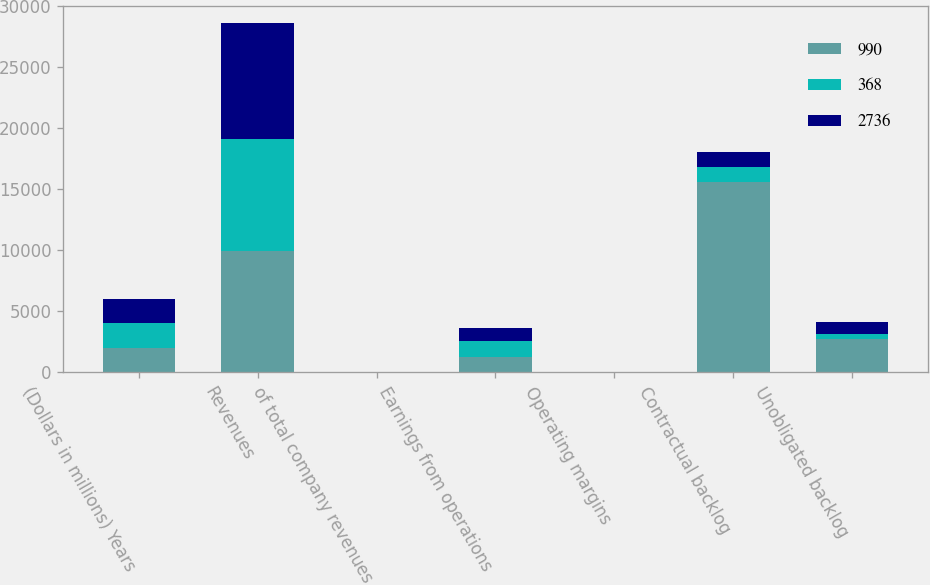Convert chart to OTSL. <chart><loc_0><loc_0><loc_500><loc_500><stacked_bar_chart><ecel><fcel>(Dollars in millions) Years<fcel>Revenues<fcel>of total company revenues<fcel>Earnings from operations<fcel>Operating margins<fcel>Contractual backlog<fcel>Unobligated backlog<nl><fcel>990<fcel>2016<fcel>9937<fcel>11<fcel>1284<fcel>12.9<fcel>15610<fcel>2736<nl><fcel>368<fcel>2015<fcel>9213<fcel>10<fcel>1237<fcel>13.4<fcel>1237<fcel>368<nl><fcel>2736<fcel>2014<fcel>9468<fcel>10<fcel>1141<fcel>12.1<fcel>1237<fcel>990<nl></chart> 